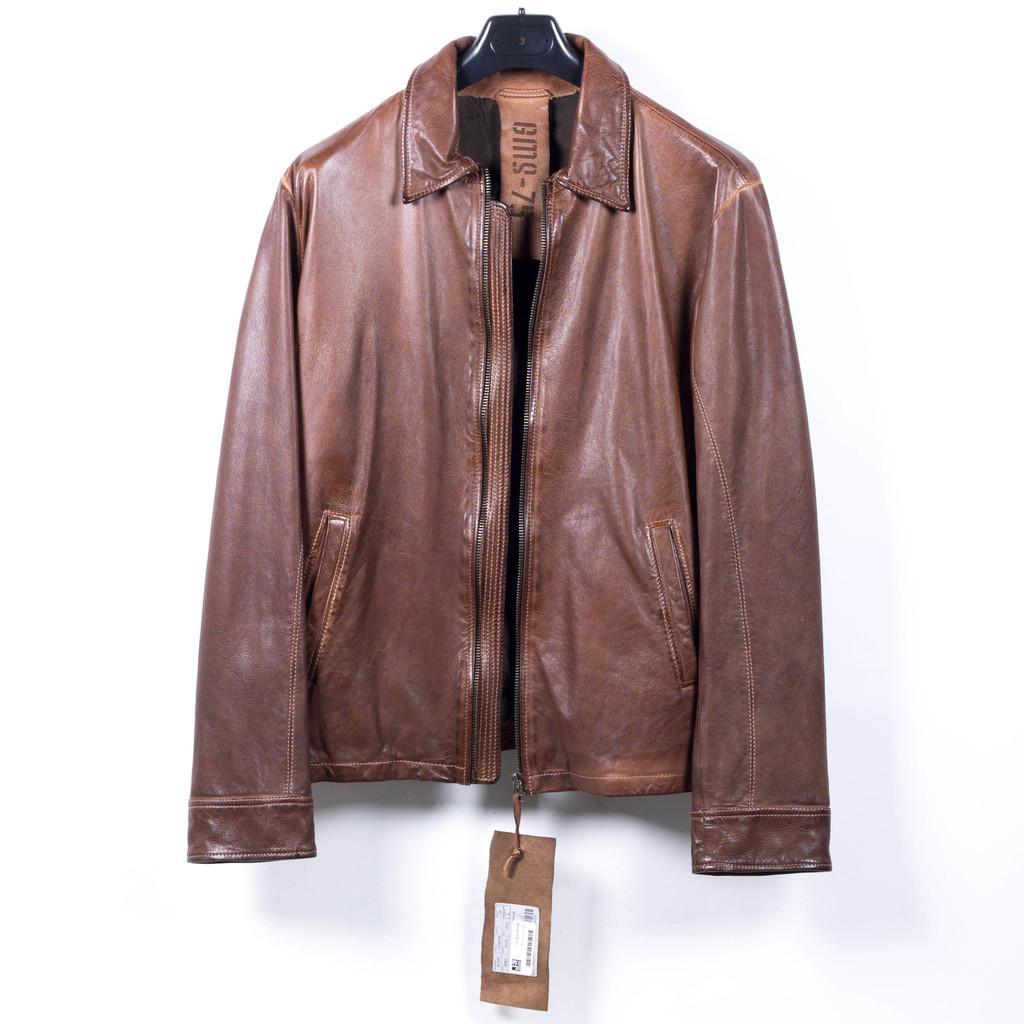Can you describe this image briefly? In this image, we can see a brown color jacket hanging on the hanger, in the background we can see the white wall. 